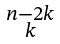Convert formula to latex. <formula><loc_0><loc_0><loc_500><loc_500>\begin{smallmatrix} { n } - 2 { k } \\ { k } \end{smallmatrix}</formula> 